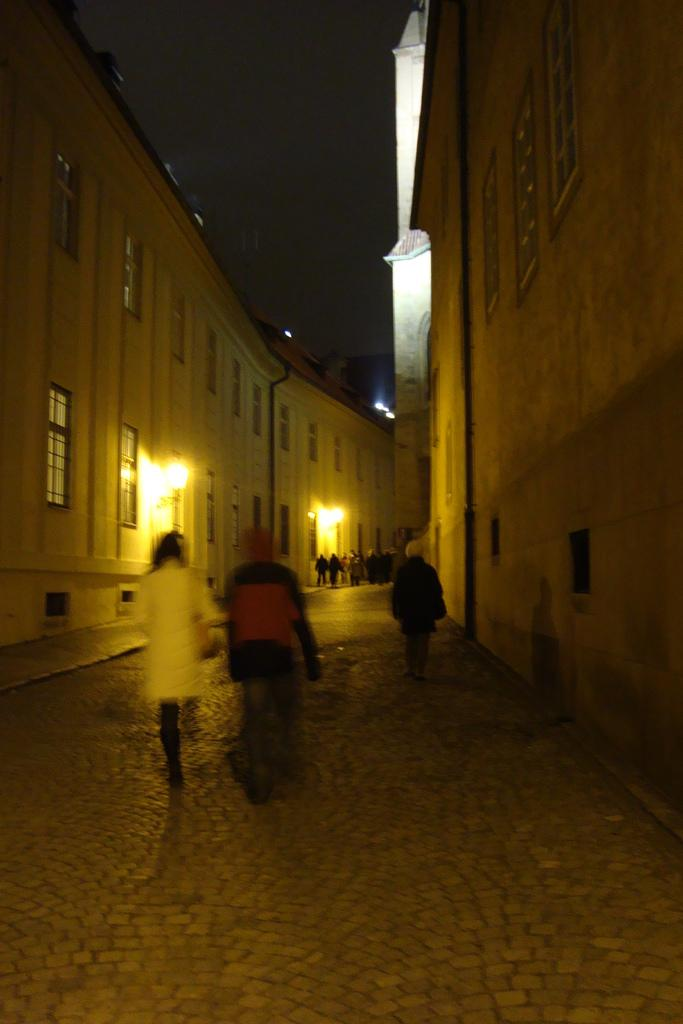What are the people in the image doing? The people in the image are walking on the road in the center. What can be seen on both sides of the image? There are buildings on both sides of the image. What is visible at the top of the image? The sky is visible at the top of the image. What feature can be observed in the buildings? There are windows present in the image. What type of joke is being told by the hen in the bath in the image? There is no hen or bath present in the image; it features people walking on the road and buildings with windows. 